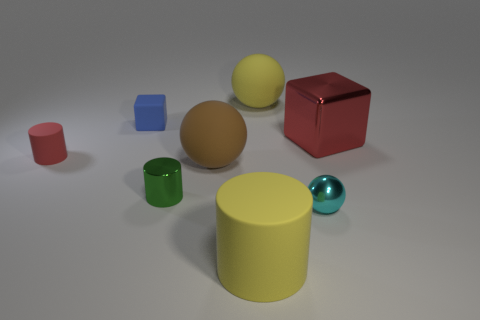Subtract all brown cylinders. Subtract all gray balls. How many cylinders are left? 3 Add 1 tiny things. How many objects exist? 9 Subtract all blocks. How many objects are left? 6 Subtract all big brown balls. Subtract all small things. How many objects are left? 3 Add 4 brown rubber spheres. How many brown rubber spheres are left? 5 Add 6 blue matte blocks. How many blue matte blocks exist? 7 Subtract 0 gray cylinders. How many objects are left? 8 